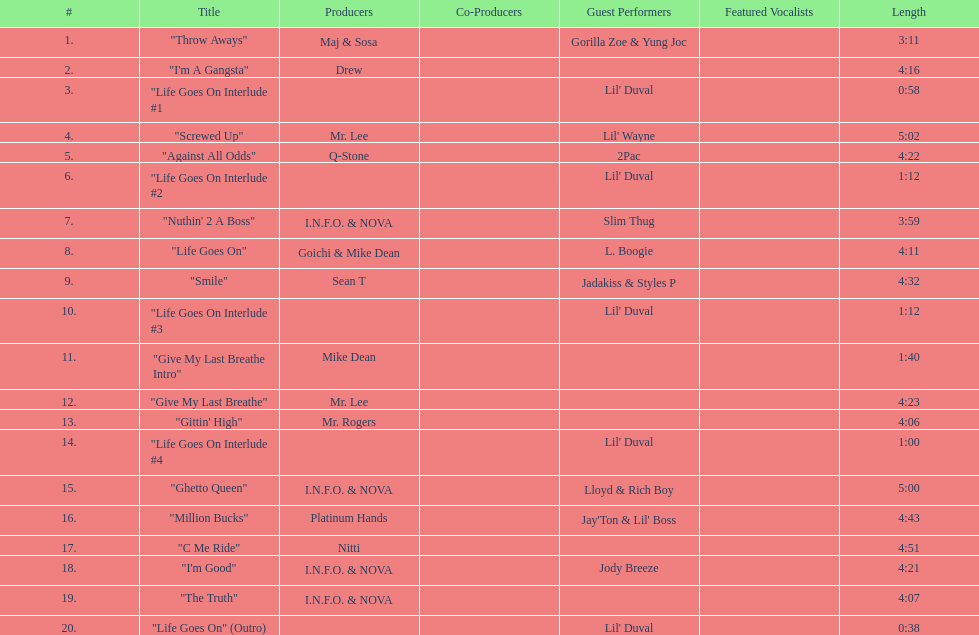Which producers produced the majority of songs on this record? I.N.F.O. & NOVA. 